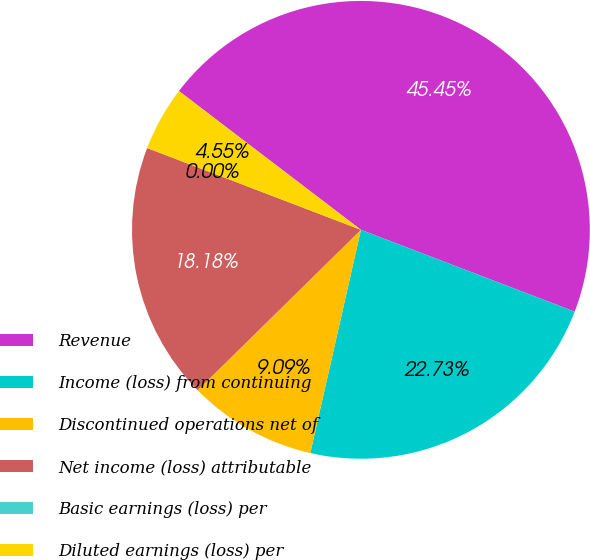Convert chart to OTSL. <chart><loc_0><loc_0><loc_500><loc_500><pie_chart><fcel>Revenue<fcel>Income (loss) from continuing<fcel>Discontinued operations net of<fcel>Net income (loss) attributable<fcel>Basic earnings (loss) per<fcel>Diluted earnings (loss) per<nl><fcel>45.45%<fcel>22.73%<fcel>9.09%<fcel>18.18%<fcel>0.0%<fcel>4.55%<nl></chart> 